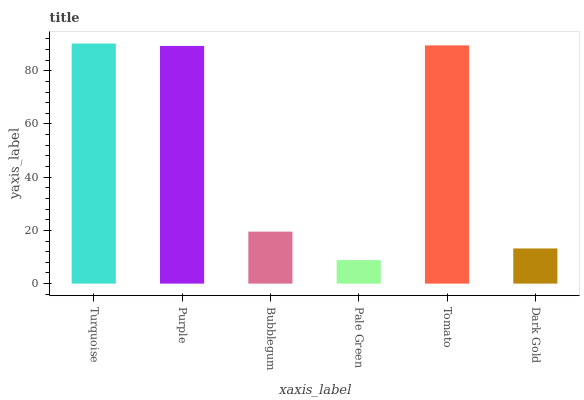Is Pale Green the minimum?
Answer yes or no. Yes. Is Turquoise the maximum?
Answer yes or no. Yes. Is Purple the minimum?
Answer yes or no. No. Is Purple the maximum?
Answer yes or no. No. Is Turquoise greater than Purple?
Answer yes or no. Yes. Is Purple less than Turquoise?
Answer yes or no. Yes. Is Purple greater than Turquoise?
Answer yes or no. No. Is Turquoise less than Purple?
Answer yes or no. No. Is Purple the high median?
Answer yes or no. Yes. Is Bubblegum the low median?
Answer yes or no. Yes. Is Bubblegum the high median?
Answer yes or no. No. Is Dark Gold the low median?
Answer yes or no. No. 